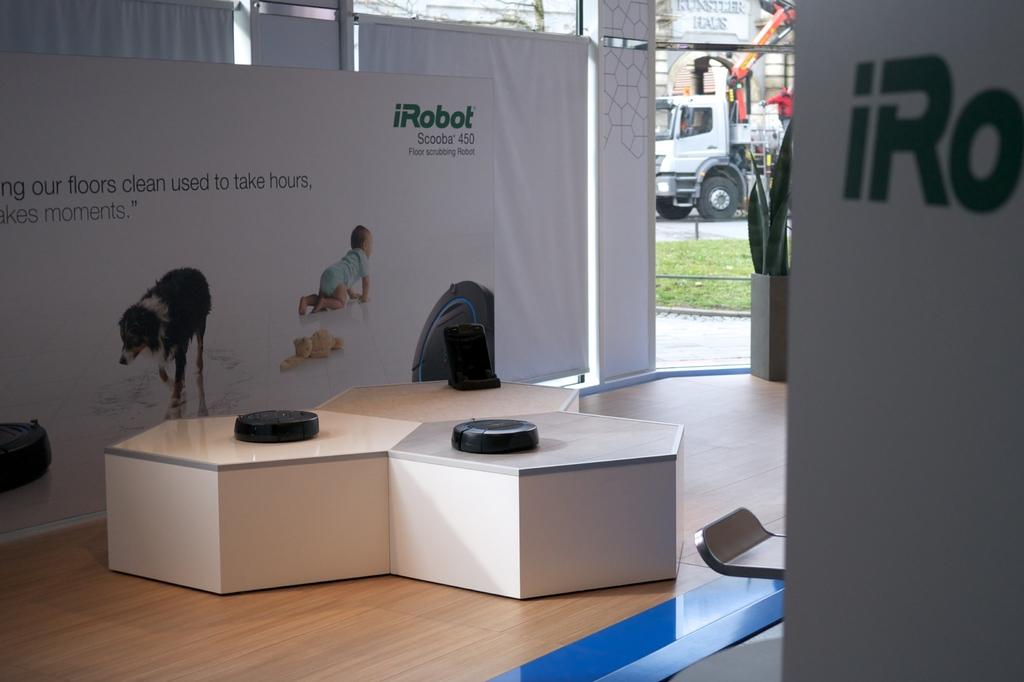What type of table is in the image? There is a design table in the image. What color are the objects on the wooden floor? The objects on the wooden floor are black. What type of signage is present in the image? There are hoardings in the image. What type of plants are in the image? There are plants with pots in the image. What can be seen in the background of the image? The background of the image includes a walkway, grass, a road, and a vehicle. What type of popcorn is being served on the design table in the image? There is no popcorn present on the design table in the image. What type of cast is visible in the image? There is no cast visible in the image. 